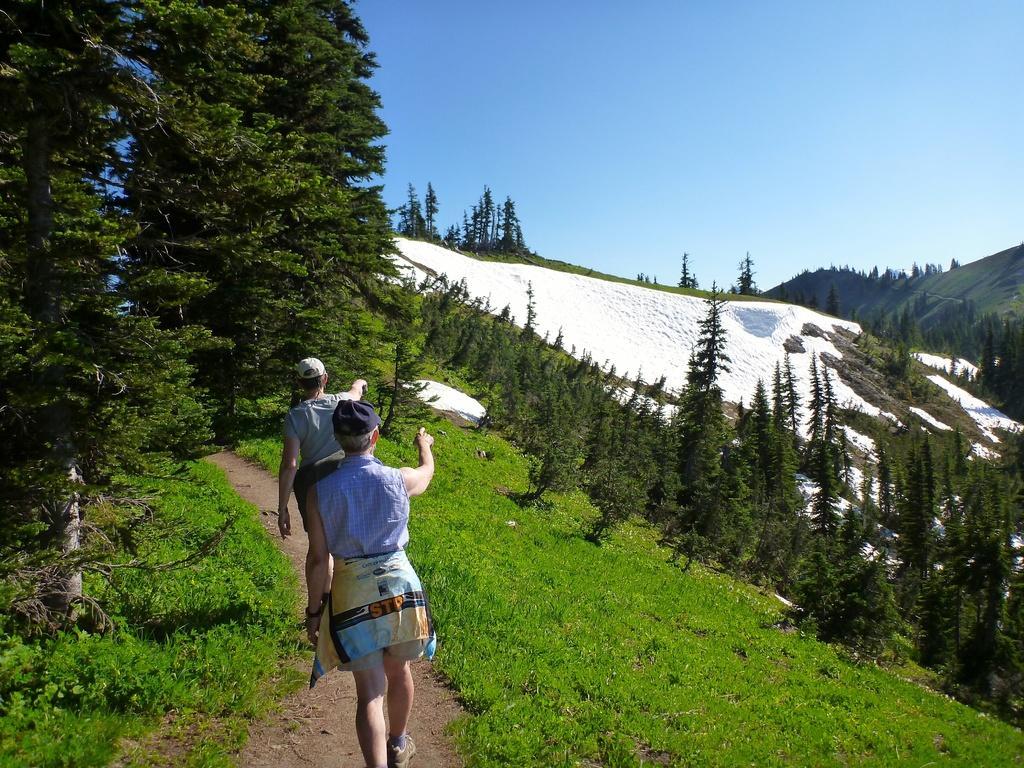Describe this image in one or two sentences. In this image there is a hill, on that hill there are two persons walking and there are trees and that hill is covered with snow, in the background there is the sky. 